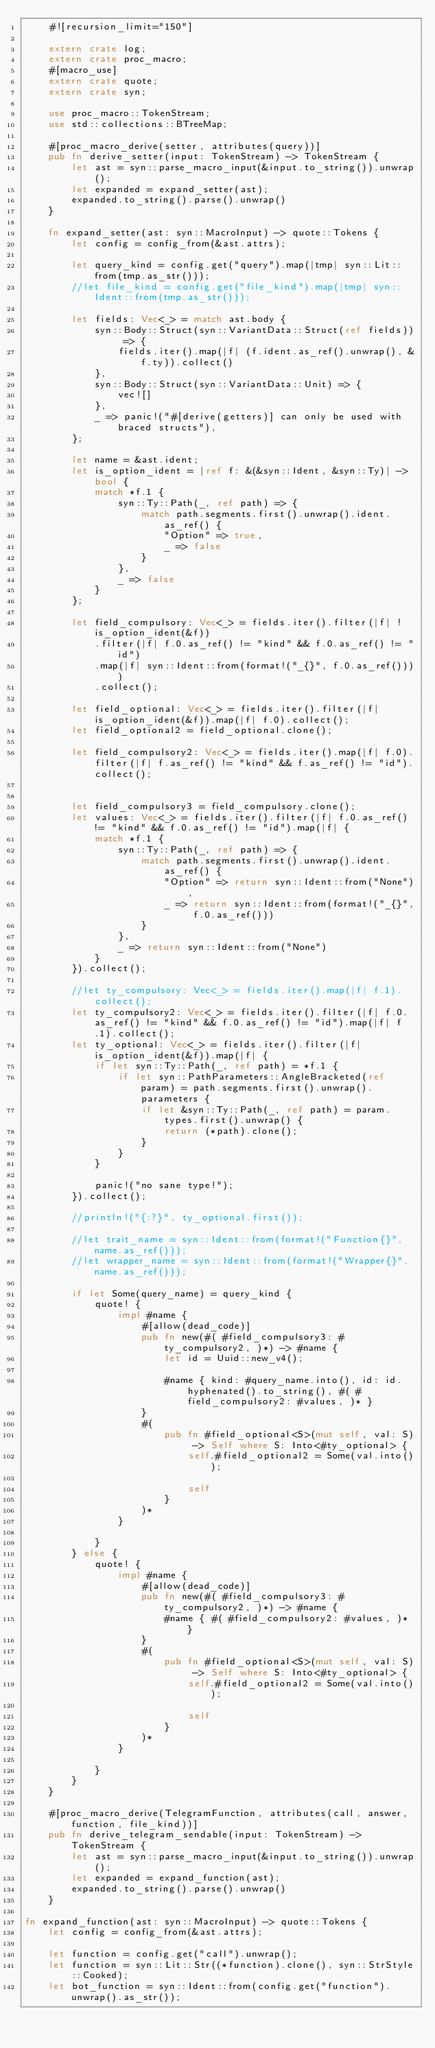Convert code to text. <code><loc_0><loc_0><loc_500><loc_500><_Rust_>    #![recursion_limit="150"]

    extern crate log;
    extern crate proc_macro;
    #[macro_use]
    extern crate quote;
    extern crate syn;

    use proc_macro::TokenStream;
    use std::collections::BTreeMap;

    #[proc_macro_derive(setter, attributes(query))]
    pub fn derive_setter(input: TokenStream) -> TokenStream {
        let ast = syn::parse_macro_input(&input.to_string()).unwrap();
        let expanded = expand_setter(ast);
        expanded.to_string().parse().unwrap()
    }

    fn expand_setter(ast: syn::MacroInput) -> quote::Tokens {
        let config = config_from(&ast.attrs);

        let query_kind = config.get("query").map(|tmp| syn::Lit::from(tmp.as_str()));
        //let file_kind = config.get("file_kind").map(|tmp| syn::Ident::from(tmp.as_str()));

        let fields: Vec<_> = match ast.body {
            syn::Body::Struct(syn::VariantData::Struct(ref fields)) => {
                fields.iter().map(|f| (f.ident.as_ref().unwrap(), &f.ty)).collect()
            },
            syn::Body::Struct(syn::VariantData::Unit) => {
                vec![]
            },
            _ => panic!("#[derive(getters)] can only be used with braced structs"),
        };

        let name = &ast.ident;
        let is_option_ident = |ref f: &(&syn::Ident, &syn::Ty)| -> bool {
            match *f.1 {
                syn::Ty::Path(_, ref path) => {
                    match path.segments.first().unwrap().ident.as_ref() {
                        "Option" => true,
                        _ => false
                    }
                },
                _ => false
            }
        };

        let field_compulsory: Vec<_> = fields.iter().filter(|f| !is_option_ident(&f))
            .filter(|f| f.0.as_ref() != "kind" && f.0.as_ref() != "id")
            .map(|f| syn::Ident::from(format!("_{}", f.0.as_ref())))
            .collect();

        let field_optional: Vec<_> = fields.iter().filter(|f| is_option_ident(&f)).map(|f| f.0).collect();
        let field_optional2 = field_optional.clone();

        let field_compulsory2: Vec<_> = fields.iter().map(|f| f.0).filter(|f| f.as_ref() != "kind" && f.as_ref() != "id").collect();


        let field_compulsory3 = field_compulsory.clone();
        let values: Vec<_> = fields.iter().filter(|f| f.0.as_ref() != "kind" && f.0.as_ref() != "id").map(|f| {
            match *f.1 {
                syn::Ty::Path(_, ref path) => {
                    match path.segments.first().unwrap().ident.as_ref() {
                        "Option" => return syn::Ident::from("None"),
                        _ => return syn::Ident::from(format!("_{}", f.0.as_ref()))
                    }
                },
                _ => return syn::Ident::from("None")
            }
        }).collect();

        //let ty_compulsory: Vec<_> = fields.iter().map(|f| f.1).collect();
        let ty_compulsory2: Vec<_> = fields.iter().filter(|f| f.0.as_ref() != "kind" && f.0.as_ref() != "id").map(|f| f.1).collect();
        let ty_optional: Vec<_> = fields.iter().filter(|f| is_option_ident(&f)).map(|f| {
            if let syn::Ty::Path(_, ref path) = *f.1 {
                if let syn::PathParameters::AngleBracketed(ref param) = path.segments.first().unwrap().parameters {
                    if let &syn::Ty::Path(_, ref path) = param.types.first().unwrap() {
                        return (*path).clone();
                    }
                }
            }

            panic!("no sane type!");
        }).collect();

        //println!("{:?}", ty_optional.first());

        //let trait_name = syn::Ident::from(format!("Function{}",  name.as_ref()));
        //let wrapper_name = syn::Ident::from(format!("Wrapper{}", name.as_ref()));

        if let Some(query_name) = query_kind {
            quote! {
                impl #name {
                    #[allow(dead_code)]
                    pub fn new(#( #field_compulsory3: #ty_compulsory2, )*) -> #name {
                        let id = Uuid::new_v4();

                        #name { kind: #query_name.into(), id: id.hyphenated().to_string(), #( #field_compulsory2: #values, )* }
                    }
                    #(
                        pub fn #field_optional<S>(mut self, val: S) -> Self where S: Into<#ty_optional> {
                            self.#field_optional2 = Some(val.into());

                            self
                        }
                    )*
                }

            }
        } else {
            quote! {
                impl #name {
                    #[allow(dead_code)]
                    pub fn new(#( #field_compulsory3: #ty_compulsory2, )*) -> #name {
                        #name { #( #field_compulsory2: #values, )* }
                    }
                    #(
                        pub fn #field_optional<S>(mut self, val: S) -> Self where S: Into<#ty_optional> {
                            self.#field_optional2 = Some(val.into());

                            self
                        }
                    )*
                }

            }
        }
    }

    #[proc_macro_derive(TelegramFunction, attributes(call, answer, function, file_kind))]
    pub fn derive_telegram_sendable(input: TokenStream) -> TokenStream {
        let ast = syn::parse_macro_input(&input.to_string()).unwrap();
        let expanded = expand_function(ast);
        expanded.to_string().parse().unwrap()
    }

fn expand_function(ast: syn::MacroInput) -> quote::Tokens {
    let config = config_from(&ast.attrs);

    let function = config.get("call").unwrap();
    let function = syn::Lit::Str((*function).clone(), syn::StrStyle::Cooked);
    let bot_function = syn::Ident::from(config.get("function").unwrap().as_str());</code> 